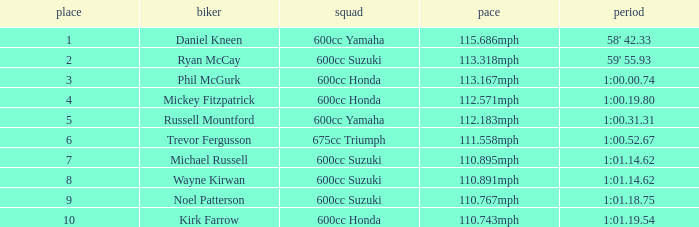How many ranks have michael russell as the rider? 7.0. 